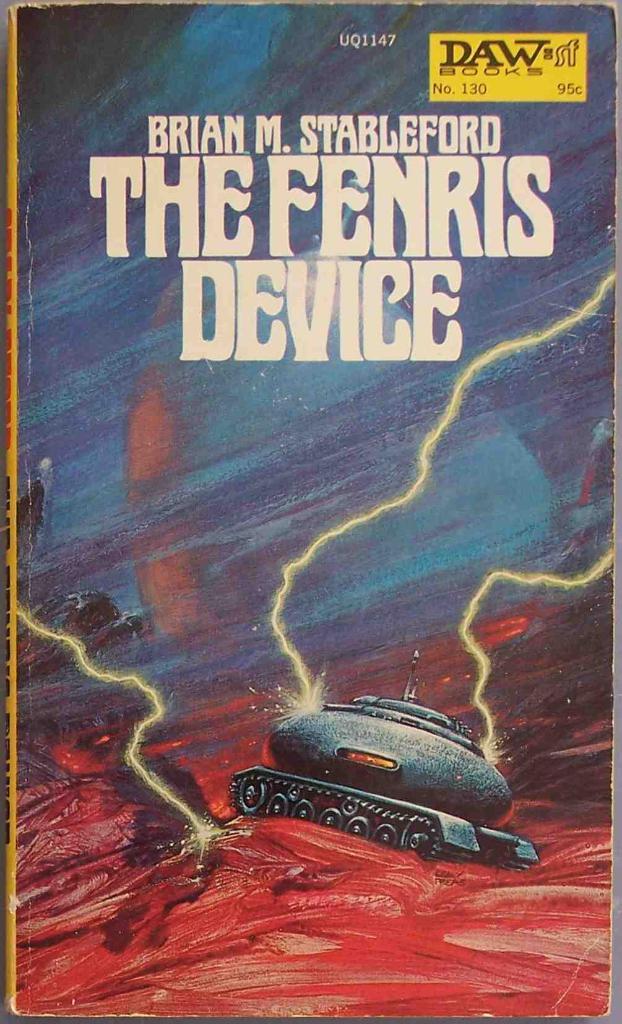What is the title of the book?
Provide a succinct answer. The fenris device. 